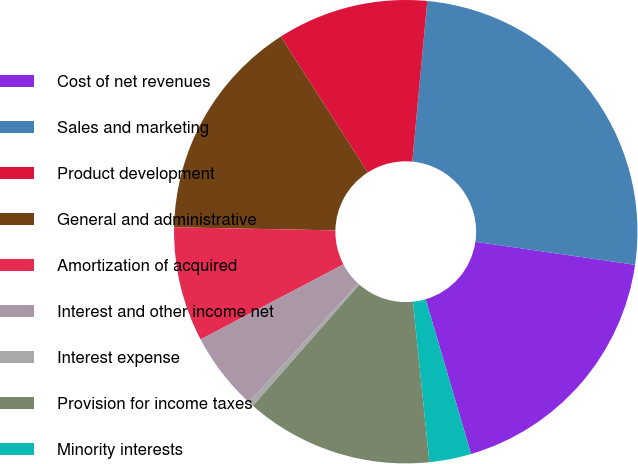Convert chart to OTSL. <chart><loc_0><loc_0><loc_500><loc_500><pie_chart><fcel>Cost of net revenues<fcel>Sales and marketing<fcel>Product development<fcel>General and administrative<fcel>Amortization of acquired<fcel>Interest and other income net<fcel>Interest expense<fcel>Provision for income taxes<fcel>Minority interests<nl><fcel>18.17%<fcel>25.8%<fcel>10.55%<fcel>15.63%<fcel>8.0%<fcel>5.46%<fcel>0.38%<fcel>13.09%<fcel>2.92%<nl></chart> 